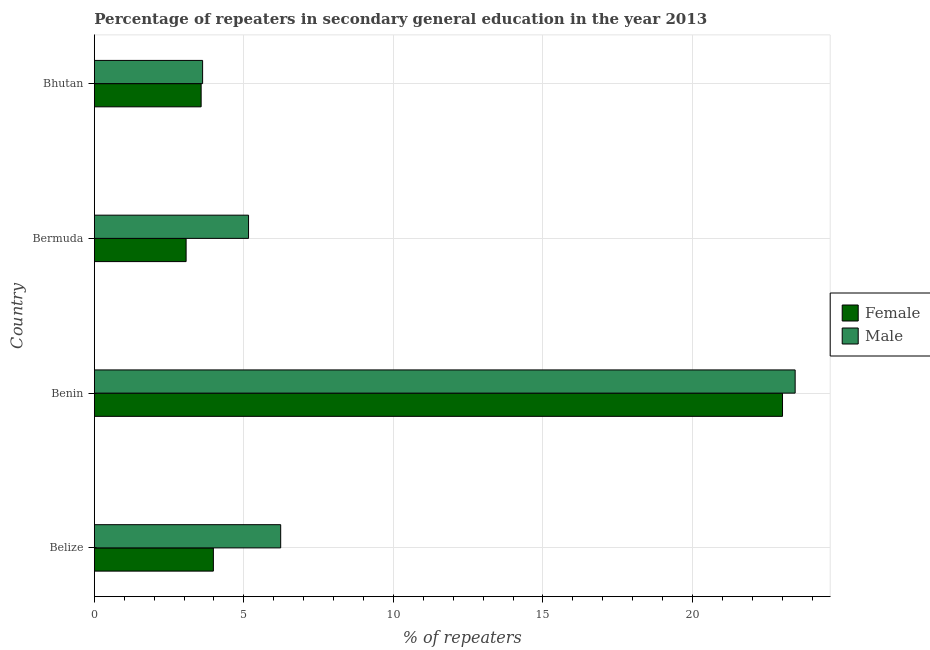How many groups of bars are there?
Provide a short and direct response. 4. Are the number of bars per tick equal to the number of legend labels?
Offer a terse response. Yes. Are the number of bars on each tick of the Y-axis equal?
Provide a short and direct response. Yes. How many bars are there on the 3rd tick from the bottom?
Your answer should be very brief. 2. What is the label of the 3rd group of bars from the top?
Provide a succinct answer. Benin. In how many cases, is the number of bars for a given country not equal to the number of legend labels?
Your response must be concise. 0. What is the percentage of female repeaters in Bermuda?
Provide a short and direct response. 3.07. Across all countries, what is the maximum percentage of female repeaters?
Your response must be concise. 23.01. Across all countries, what is the minimum percentage of female repeaters?
Make the answer very short. 3.07. In which country was the percentage of female repeaters maximum?
Give a very brief answer. Benin. In which country was the percentage of female repeaters minimum?
Your answer should be compact. Bermuda. What is the total percentage of male repeaters in the graph?
Your response must be concise. 38.44. What is the difference between the percentage of male repeaters in Belize and that in Bermuda?
Offer a terse response. 1.07. What is the difference between the percentage of male repeaters in Bermuda and the percentage of female repeaters in Bhutan?
Keep it short and to the point. 1.58. What is the average percentage of female repeaters per country?
Your answer should be very brief. 8.41. What is the difference between the percentage of male repeaters and percentage of female repeaters in Benin?
Offer a terse response. 0.42. In how many countries, is the percentage of female repeaters greater than 16 %?
Your answer should be compact. 1. What is the ratio of the percentage of male repeaters in Bermuda to that in Bhutan?
Your answer should be very brief. 1.42. Is the difference between the percentage of male repeaters in Benin and Bermuda greater than the difference between the percentage of female repeaters in Benin and Bermuda?
Make the answer very short. No. What is the difference between the highest and the second highest percentage of female repeaters?
Offer a terse response. 19.03. What is the difference between the highest and the lowest percentage of male repeaters?
Provide a short and direct response. 19.81. In how many countries, is the percentage of female repeaters greater than the average percentage of female repeaters taken over all countries?
Ensure brevity in your answer.  1. Is the sum of the percentage of male repeaters in Belize and Bermuda greater than the maximum percentage of female repeaters across all countries?
Make the answer very short. No. How many bars are there?
Offer a terse response. 8. Are the values on the major ticks of X-axis written in scientific E-notation?
Provide a succinct answer. No. Does the graph contain grids?
Your response must be concise. Yes. Where does the legend appear in the graph?
Ensure brevity in your answer.  Center right. How many legend labels are there?
Offer a terse response. 2. What is the title of the graph?
Your answer should be compact. Percentage of repeaters in secondary general education in the year 2013. What is the label or title of the X-axis?
Provide a short and direct response. % of repeaters. What is the % of repeaters in Female in Belize?
Provide a succinct answer. 3.98. What is the % of repeaters of Male in Belize?
Offer a terse response. 6.23. What is the % of repeaters in Female in Benin?
Offer a very short reply. 23.01. What is the % of repeaters of Male in Benin?
Offer a very short reply. 23.43. What is the % of repeaters of Female in Bermuda?
Provide a short and direct response. 3.07. What is the % of repeaters in Male in Bermuda?
Ensure brevity in your answer.  5.16. What is the % of repeaters of Female in Bhutan?
Offer a terse response. 3.57. What is the % of repeaters in Male in Bhutan?
Provide a succinct answer. 3.62. Across all countries, what is the maximum % of repeaters of Female?
Offer a terse response. 23.01. Across all countries, what is the maximum % of repeaters in Male?
Your answer should be very brief. 23.43. Across all countries, what is the minimum % of repeaters of Female?
Keep it short and to the point. 3.07. Across all countries, what is the minimum % of repeaters of Male?
Ensure brevity in your answer.  3.62. What is the total % of repeaters of Female in the graph?
Give a very brief answer. 33.63. What is the total % of repeaters in Male in the graph?
Your answer should be compact. 38.44. What is the difference between the % of repeaters of Female in Belize and that in Benin?
Keep it short and to the point. -19.03. What is the difference between the % of repeaters of Male in Belize and that in Benin?
Provide a succinct answer. -17.2. What is the difference between the % of repeaters in Female in Belize and that in Bermuda?
Ensure brevity in your answer.  0.91. What is the difference between the % of repeaters of Male in Belize and that in Bermuda?
Provide a succinct answer. 1.07. What is the difference between the % of repeaters of Female in Belize and that in Bhutan?
Make the answer very short. 0.41. What is the difference between the % of repeaters in Male in Belize and that in Bhutan?
Make the answer very short. 2.61. What is the difference between the % of repeaters of Female in Benin and that in Bermuda?
Keep it short and to the point. 19.94. What is the difference between the % of repeaters of Male in Benin and that in Bermuda?
Your response must be concise. 18.28. What is the difference between the % of repeaters in Female in Benin and that in Bhutan?
Your answer should be compact. 19.44. What is the difference between the % of repeaters in Male in Benin and that in Bhutan?
Provide a short and direct response. 19.81. What is the difference between the % of repeaters of Female in Bermuda and that in Bhutan?
Your response must be concise. -0.5. What is the difference between the % of repeaters in Male in Bermuda and that in Bhutan?
Your answer should be compact. 1.54. What is the difference between the % of repeaters of Female in Belize and the % of repeaters of Male in Benin?
Your answer should be compact. -19.45. What is the difference between the % of repeaters in Female in Belize and the % of repeaters in Male in Bermuda?
Ensure brevity in your answer.  -1.18. What is the difference between the % of repeaters of Female in Belize and the % of repeaters of Male in Bhutan?
Provide a short and direct response. 0.36. What is the difference between the % of repeaters in Female in Benin and the % of repeaters in Male in Bermuda?
Give a very brief answer. 17.85. What is the difference between the % of repeaters in Female in Benin and the % of repeaters in Male in Bhutan?
Ensure brevity in your answer.  19.39. What is the difference between the % of repeaters in Female in Bermuda and the % of repeaters in Male in Bhutan?
Provide a short and direct response. -0.55. What is the average % of repeaters in Female per country?
Make the answer very short. 8.41. What is the average % of repeaters of Male per country?
Offer a terse response. 9.61. What is the difference between the % of repeaters in Female and % of repeaters in Male in Belize?
Ensure brevity in your answer.  -2.25. What is the difference between the % of repeaters of Female and % of repeaters of Male in Benin?
Provide a short and direct response. -0.42. What is the difference between the % of repeaters in Female and % of repeaters in Male in Bermuda?
Make the answer very short. -2.09. What is the difference between the % of repeaters of Female and % of repeaters of Male in Bhutan?
Your answer should be compact. -0.05. What is the ratio of the % of repeaters in Female in Belize to that in Benin?
Your answer should be very brief. 0.17. What is the ratio of the % of repeaters of Male in Belize to that in Benin?
Your answer should be very brief. 0.27. What is the ratio of the % of repeaters of Female in Belize to that in Bermuda?
Keep it short and to the point. 1.3. What is the ratio of the % of repeaters of Male in Belize to that in Bermuda?
Keep it short and to the point. 1.21. What is the ratio of the % of repeaters in Female in Belize to that in Bhutan?
Your response must be concise. 1.11. What is the ratio of the % of repeaters in Male in Belize to that in Bhutan?
Offer a very short reply. 1.72. What is the ratio of the % of repeaters in Female in Benin to that in Bermuda?
Ensure brevity in your answer.  7.5. What is the ratio of the % of repeaters of Male in Benin to that in Bermuda?
Provide a succinct answer. 4.54. What is the ratio of the % of repeaters of Female in Benin to that in Bhutan?
Offer a very short reply. 6.44. What is the ratio of the % of repeaters in Male in Benin to that in Bhutan?
Your answer should be very brief. 6.47. What is the ratio of the % of repeaters in Female in Bermuda to that in Bhutan?
Provide a short and direct response. 0.86. What is the ratio of the % of repeaters in Male in Bermuda to that in Bhutan?
Offer a terse response. 1.42. What is the difference between the highest and the second highest % of repeaters in Female?
Your response must be concise. 19.03. What is the difference between the highest and the second highest % of repeaters in Male?
Give a very brief answer. 17.2. What is the difference between the highest and the lowest % of repeaters of Female?
Your answer should be very brief. 19.94. What is the difference between the highest and the lowest % of repeaters in Male?
Provide a succinct answer. 19.81. 